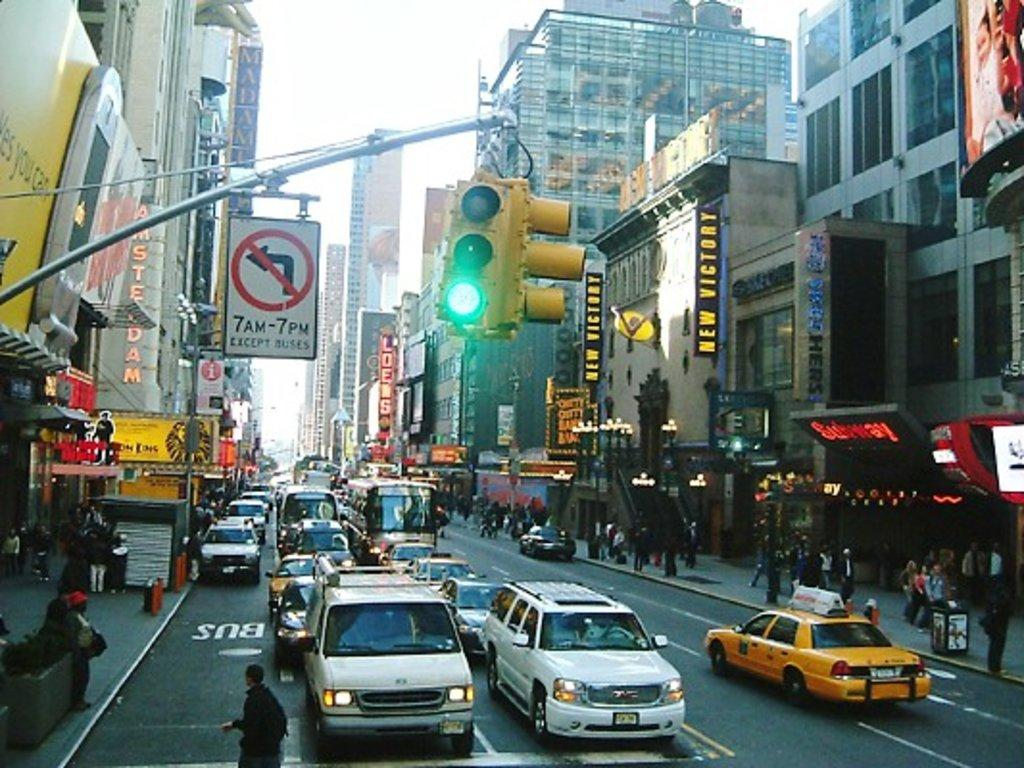<image>
Give a short and clear explanation of the subsequent image. A very busy downtown street shows that it is prohibited to turn left from 7AM to 7PM except for buses. 